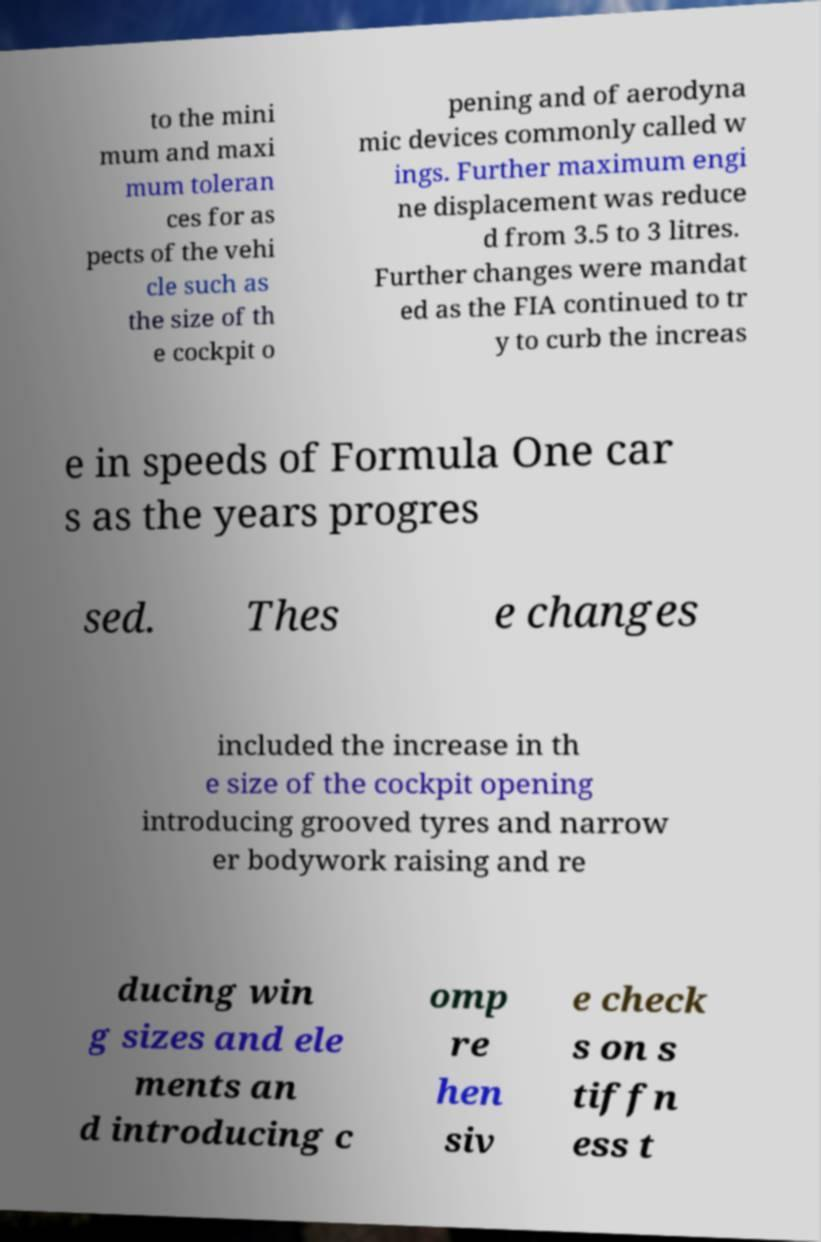Can you accurately transcribe the text from the provided image for me? to the mini mum and maxi mum toleran ces for as pects of the vehi cle such as the size of th e cockpit o pening and of aerodyna mic devices commonly called w ings. Further maximum engi ne displacement was reduce d from 3.5 to 3 litres. Further changes were mandat ed as the FIA continued to tr y to curb the increas e in speeds of Formula One car s as the years progres sed. Thes e changes included the increase in th e size of the cockpit opening introducing grooved tyres and narrow er bodywork raising and re ducing win g sizes and ele ments an d introducing c omp re hen siv e check s on s tiffn ess t 